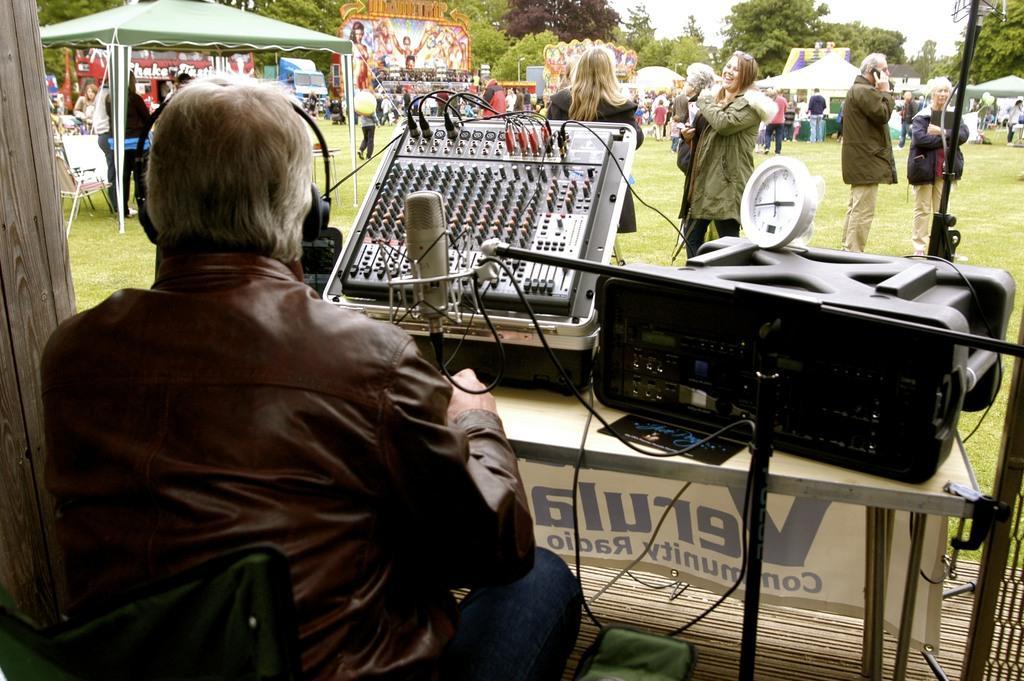Describe this image in one or two sentences. In this image I can see a person wearing brown colored jacket and jeans is sitting and I can see he is wearing headphones which are black in color. I can see a microphone and a musical system in front of him. In the background I can see number of persons standing on the ground, a tent which is green in color, few other tents, few trees and the sky. 